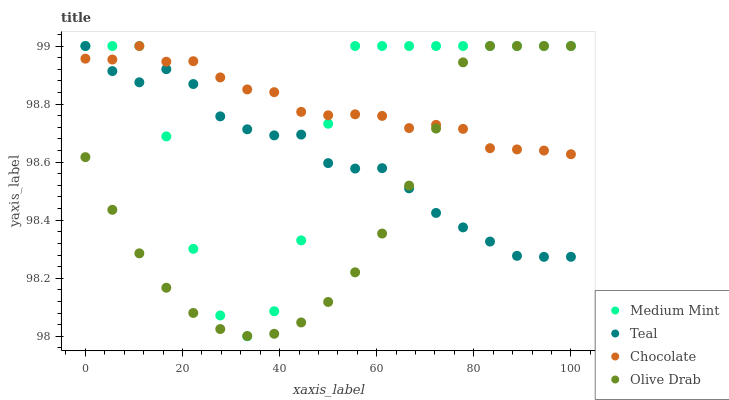Does Olive Drab have the minimum area under the curve?
Answer yes or no. Yes. Does Chocolate have the maximum area under the curve?
Answer yes or no. Yes. Does Teal have the minimum area under the curve?
Answer yes or no. No. Does Teal have the maximum area under the curve?
Answer yes or no. No. Is Olive Drab the smoothest?
Answer yes or no. Yes. Is Medium Mint the roughest?
Answer yes or no. Yes. Is Teal the smoothest?
Answer yes or no. No. Is Teal the roughest?
Answer yes or no. No. Does Medium Mint have the lowest value?
Answer yes or no. Yes. Does Olive Drab have the lowest value?
Answer yes or no. No. Does Chocolate have the highest value?
Answer yes or no. Yes. Does Teal intersect Olive Drab?
Answer yes or no. Yes. Is Teal less than Olive Drab?
Answer yes or no. No. Is Teal greater than Olive Drab?
Answer yes or no. No. 